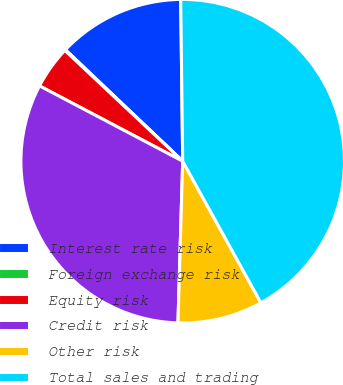Convert chart. <chart><loc_0><loc_0><loc_500><loc_500><pie_chart><fcel>Interest rate risk<fcel>Foreign exchange risk<fcel>Equity risk<fcel>Credit risk<fcel>Other risk<fcel>Total sales and trading<nl><fcel>12.71%<fcel>0.09%<fcel>4.3%<fcel>32.24%<fcel>8.5%<fcel>42.16%<nl></chart> 